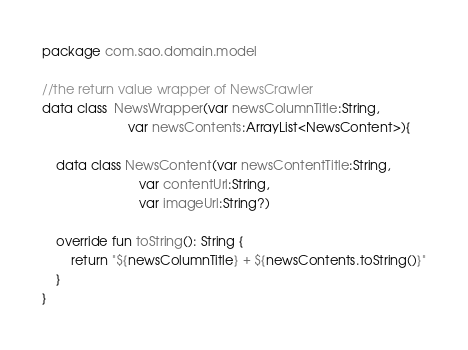<code> <loc_0><loc_0><loc_500><loc_500><_Kotlin_>package com.sao.domain.model

//the return value wrapper of NewsCrawler
data class  NewsWrapper(var newsColumnTitle:String,
                        var newsContents:ArrayList<NewsContent>){

    data class NewsContent(var newsContentTitle:String,
                           var contentUrl:String,
                           var imageUrl:String?)

    override fun toString(): String {
        return "${newsColumnTitle} + ${newsContents.toString()}"
    }
}</code> 